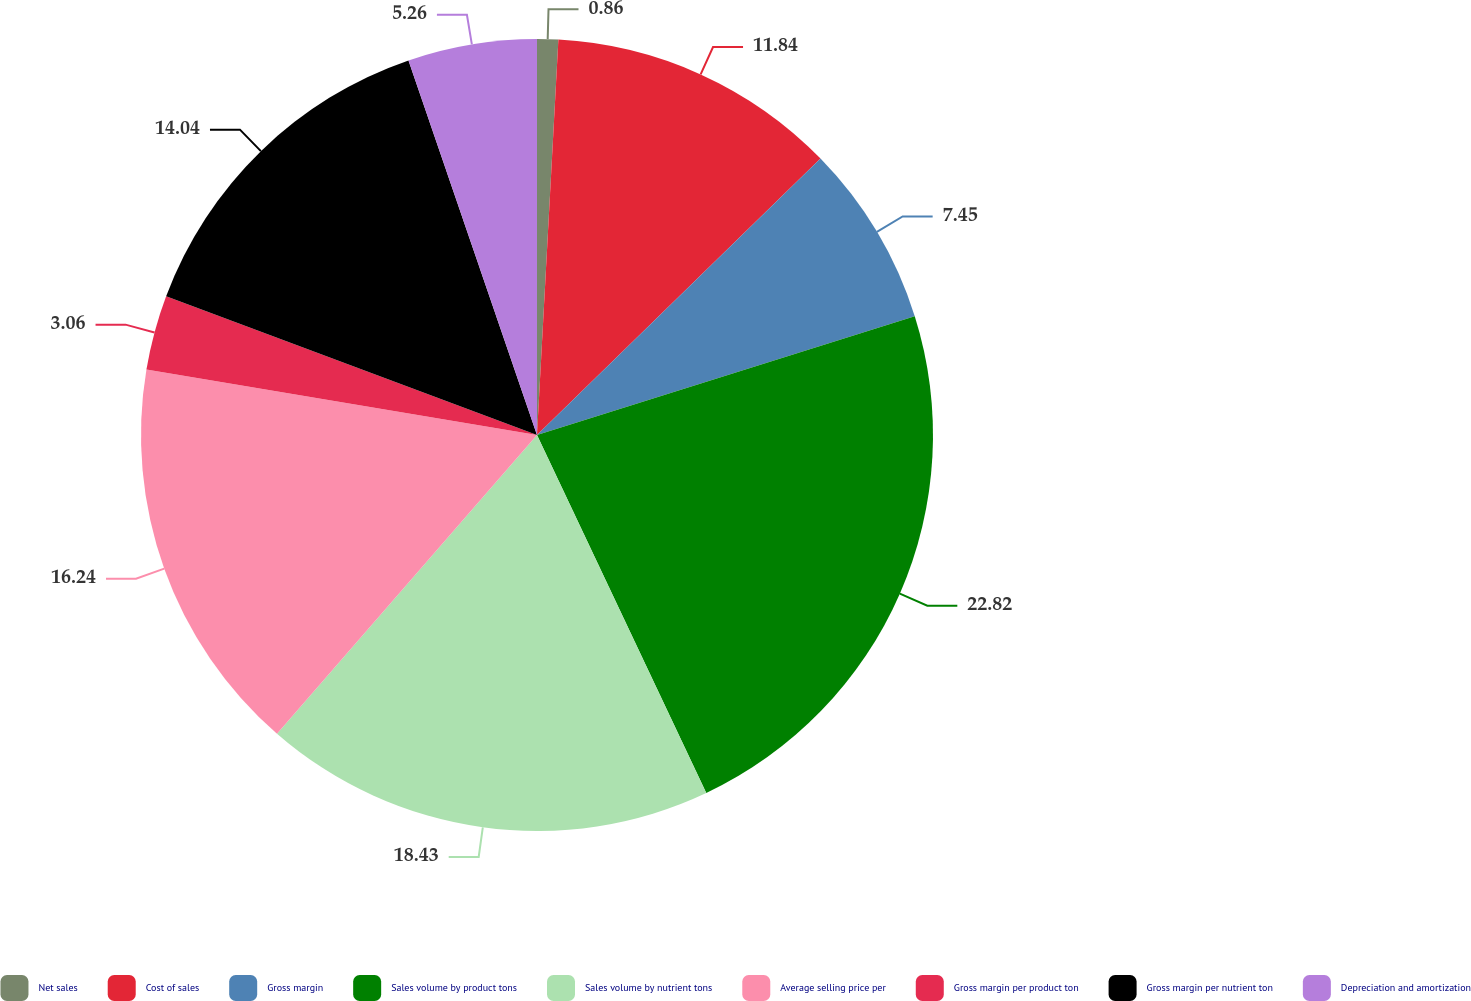Convert chart. <chart><loc_0><loc_0><loc_500><loc_500><pie_chart><fcel>Net sales<fcel>Cost of sales<fcel>Gross margin<fcel>Sales volume by product tons<fcel>Sales volume by nutrient tons<fcel>Average selling price per<fcel>Gross margin per product ton<fcel>Gross margin per nutrient ton<fcel>Depreciation and amortization<nl><fcel>0.86%<fcel>11.84%<fcel>7.45%<fcel>22.82%<fcel>18.43%<fcel>16.24%<fcel>3.06%<fcel>14.04%<fcel>5.26%<nl></chart> 